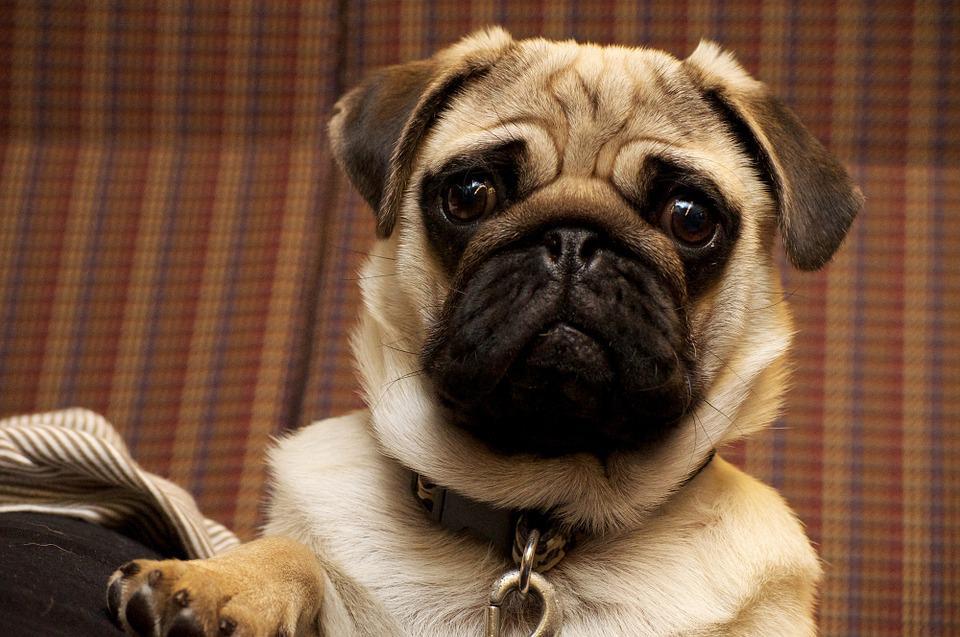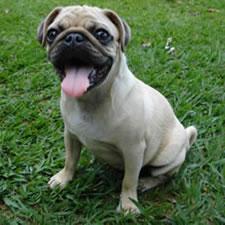The first image is the image on the left, the second image is the image on the right. For the images displayed, is the sentence "One of the dogs is sitting on the grass." factually correct? Answer yes or no. Yes. 